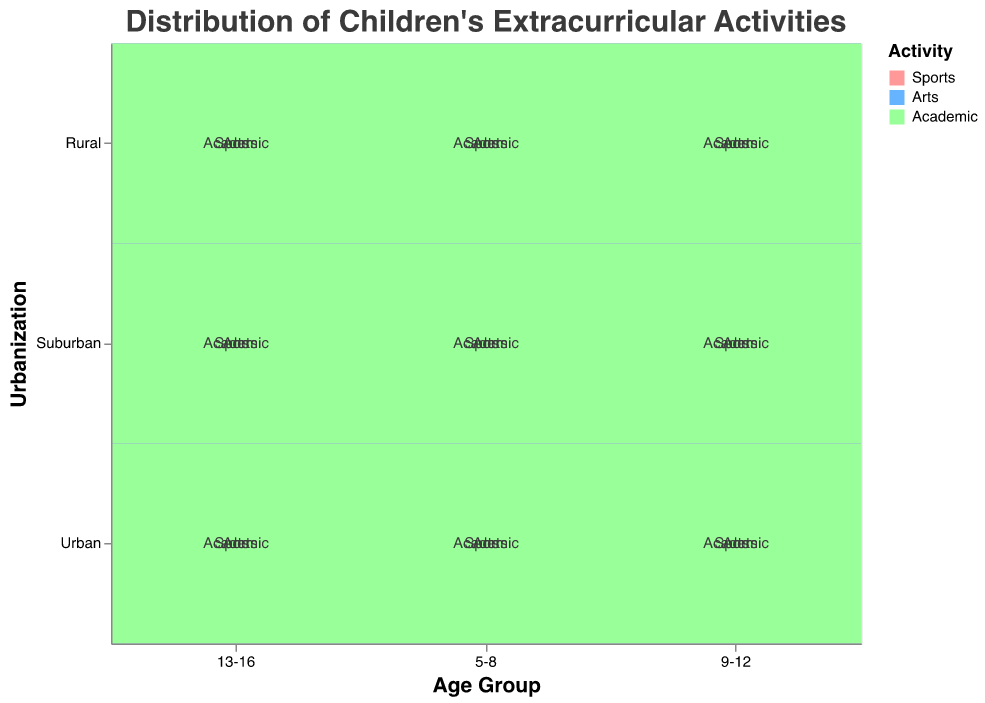What is the most popular activity for children aged 5-8 in rural areas? Look at the Rural row and locate the corresponding column for the age group 5-8, observe the size of the rectangle for each activity. The largest rectangle represents Sports.
Answer: Sports What activity has the least participation among children aged 9-12 in suburban areas? Look at the Suburban row and find the column for the age group 9-12, observe the size of the rectangle for each activity. The smallest rectangle represents Arts.
Answer: Arts Which age group has the highest percentage of children participating in academic activities in urban areas? Look at the Urban row and locate each column for age groups, then identify which column has the biggest rectangle for Academic activities. The largest rectangle for Academic is in the 13-16 age group.
Answer: 13-16 What are the activities with equal participation percentages for children aged 5-8 in suburban areas? Look at the Suburban row and find the column for the age group 5-8, then compare the sizes of the rectangles. Arts and Academic activities have the same size rectangles (both 15%).
Answer: Arts and Academic Among children aged 13-16 in rural areas, which activity has the largest decrease in participation percentage compared to children aged 9-12 in the same area? Compare the Rural row for the age groups 13-16 and 9-12, and look at the differences in rectangles sizes for each activity. The largest drop is for Arts, which drops from 10% to 5%.
Answer: Arts How does the participation in sports change as children grow older in urban areas? Look at the Urban row and observe the change in the Sports rectangles across the age groups. For age group 5-8 it is 30%, 9-12 it is 35%, and 13-16 it is 30%.
Answer: It increases from 5-8 to 9-12, then remains the same from 9-12 to 13-16 What is the overall trend in participation in arts activities as children grow from 5-8 to 13-16 across all urbanization levels? Look at the Arts rectangles for each age group across all urbanization levels and observe the change in size. In Urban, it decreases from 25% to 15%, in Suburban it decreases from 20% to 10%, and in Rural it decreases from 15% to 5%.
Answer: Decreasing Compare the participation in academic activities for children aged 5-8 in urban areas versus children aged 13-16 in suburban areas. Look at the Urban row and column for the age group 5-8 for Academic activities, and compare the size of the rectangle with the Suburban row and column for the age group 13-16 for Academic activities. The participation is 20% for 5-8 Urban and 30% for 13-16 Suburban.
Answer: Higher in 13-16 Suburban Which urbanization level shows the highest consistency in percentage of children participating in sports across all age groups? Compare the size of the Sports rectangles across all age groups within each urbanization level. The levels are Urban (30%, 35%, 30%), Suburban (35%, 40%, 35%), and Rural (40%, 45%, 40%). The most consistent one is Urban.
Answer: Urban 